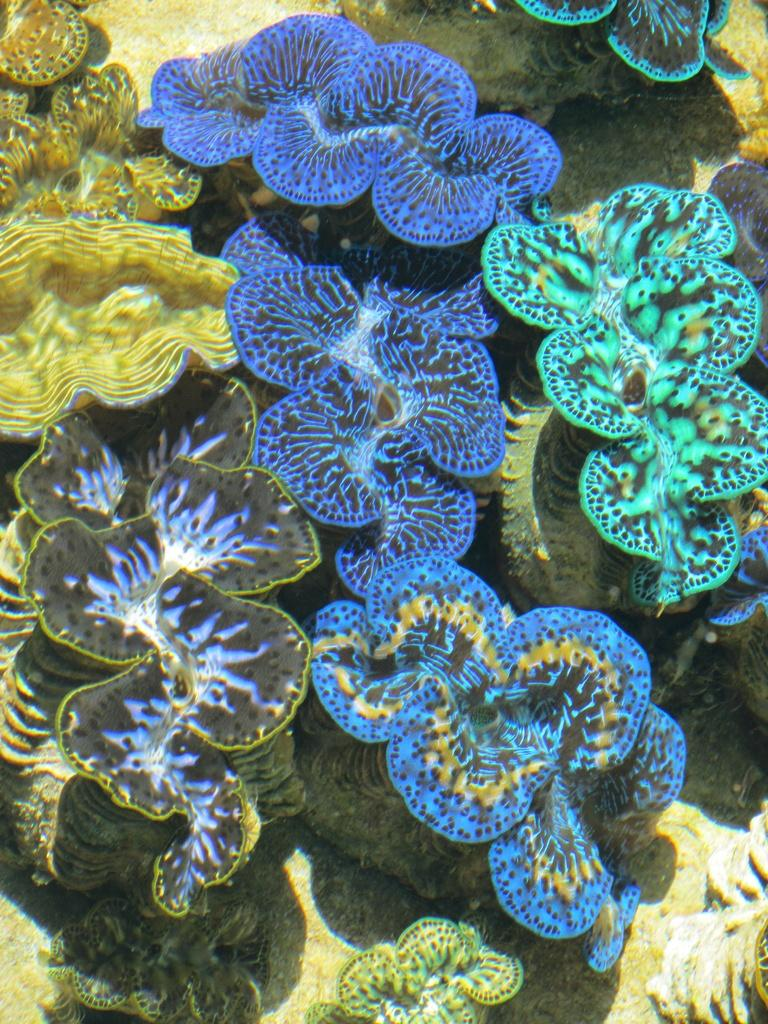What type of living organisms can be seen in the image? There are water species in the image. Can you describe the appearance of the water species? The water species have different colors. What type of island can be seen in the image? There is no island present in the image; it features water species with different colors. What kind of fowl is visible in the image? There is no fowl present in the image; it features water species with different colors. 